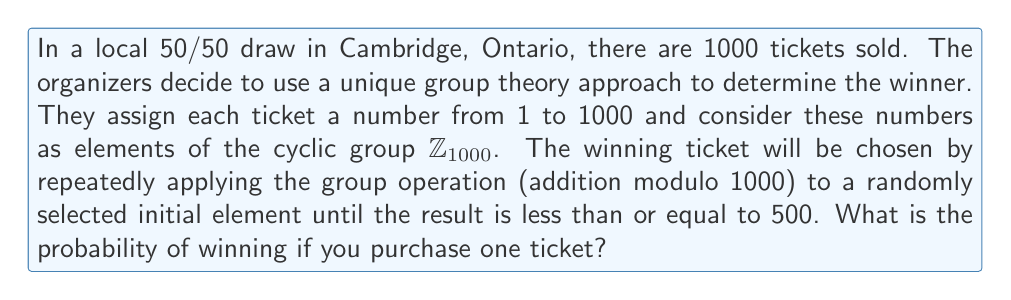What is the answer to this math problem? To solve this problem using group theory, we need to consider the properties of the cyclic group $\mathbb{Z}_{1000}$ and how the selection process works.

1) First, let's consider the structure of $\mathbb{Z}_{1000}$:
   - It's a cyclic group with 1000 elements, labeled 0 to 999.
   - The group operation is addition modulo 1000.

2) The selection process can be described as follows:
   - Start with a random element $a \in \mathbb{Z}_{1000}$.
   - Repeatedly apply the group operation: $a + a \equiv b \pmod{1000}$, $b + b \equiv c \pmod{1000}$, etc.
   - Stop when the result is less than or equal to 500.

3) Let's analyze how this process behaves:
   - If $a \leq 500$, it stops immediately and $a$ is the winning number.
   - If $500 < a < 1000$, then $a + a \equiv 2a - 1000 \pmod{1000}$ (since $1000 < 2a < 2000$).

4) We can see that for any starting number $a > 500$, the process will eventually reach a number $\leq 500$.

5) Therefore, each number from 1 to 500 has an equal chance of being the final result.

6) Since there are 500 possible winning numbers out of 1000 total tickets, the probability of winning is:

   $$P(\text{winning}) = \frac{\text{number of winning tickets}}{\text{total number of tickets}} = \frac{500}{1000} = \frac{1}{2}$$

This result aligns with the nature of a 50/50 draw, where half of the tickets are winners.
Answer: The probability of winning the 50/50 draw with one ticket is $\frac{1}{2}$ or 0.5 or 50%. 